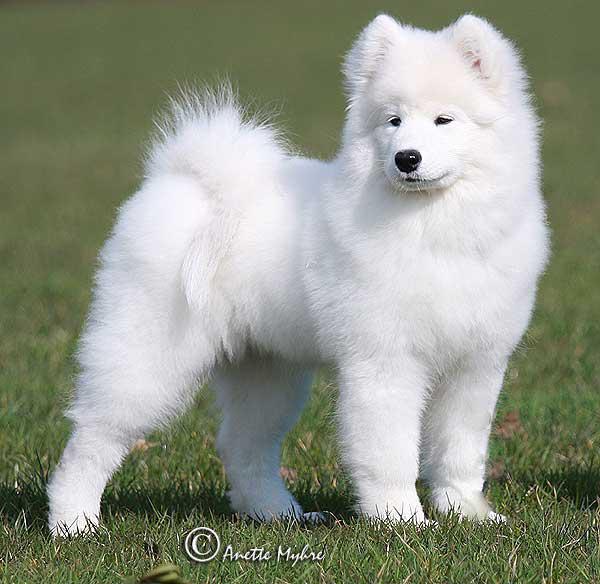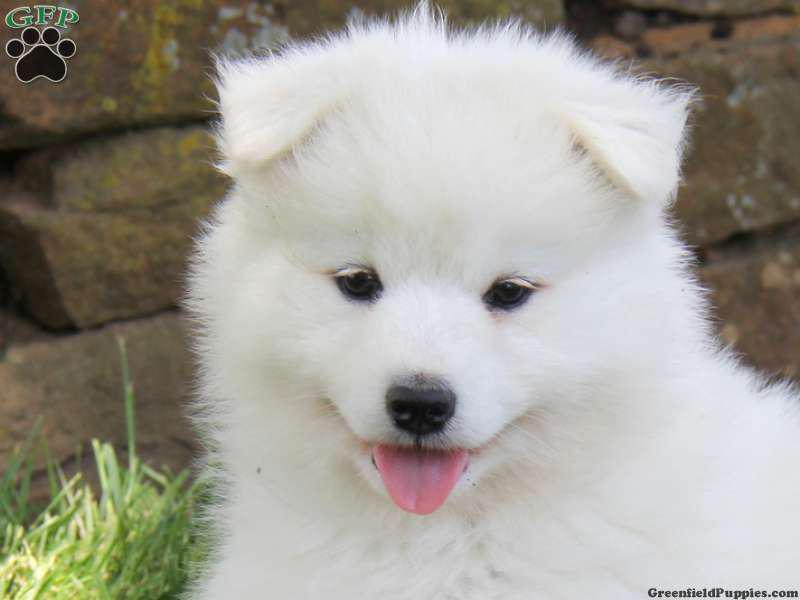The first image is the image on the left, the second image is the image on the right. Assess this claim about the two images: "There are at least two dogs in the image on the left". Correct or not? Answer yes or no. No. The first image is the image on the left, the second image is the image on the right. Assess this claim about the two images: "One image contains at least two dogs.". Correct or not? Answer yes or no. No. 